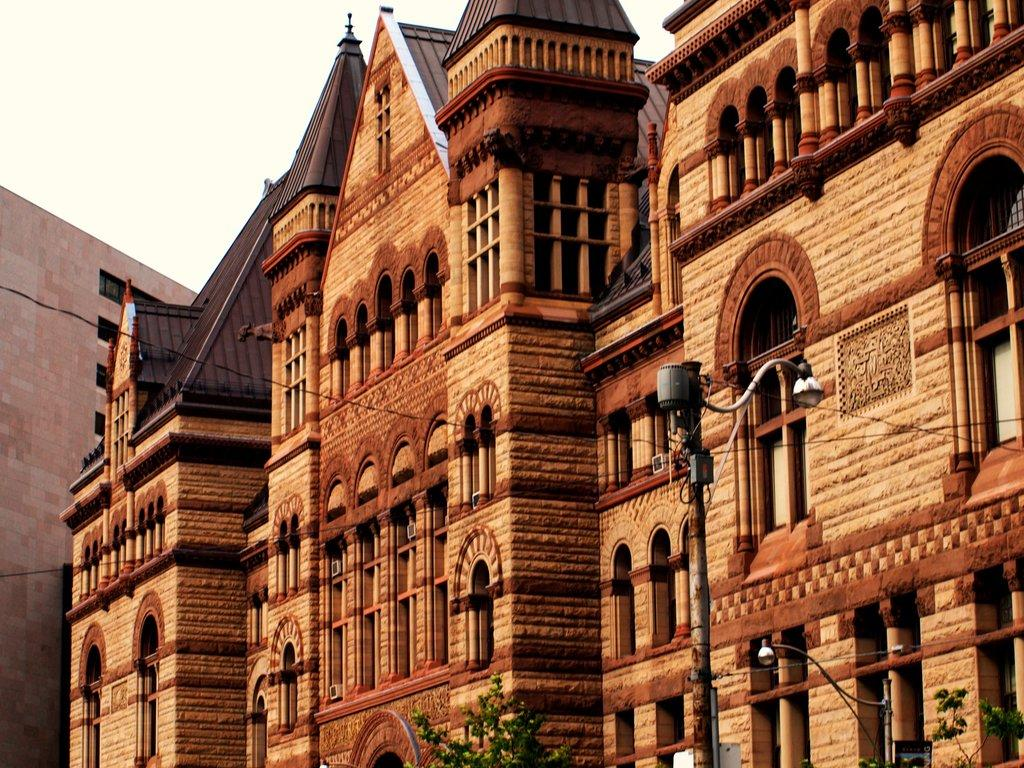What type of structures can be seen in the image? There is a group of buildings in the image. What else is present in the image besides the buildings? There are poles and trees visible in the image. What can be seen in the background of the image? The sky is visible in the image. What type of straw is being used to talk to the trees in the image? There is no straw or talking to trees present in the image. 